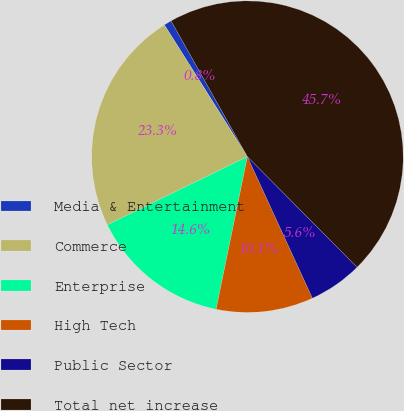Convert chart to OTSL. <chart><loc_0><loc_0><loc_500><loc_500><pie_chart><fcel>Media & Entertainment<fcel>Commerce<fcel>Enterprise<fcel>High Tech<fcel>Public Sector<fcel>Total net increase<nl><fcel>0.8%<fcel>23.26%<fcel>14.57%<fcel>10.07%<fcel>5.58%<fcel>45.72%<nl></chart> 